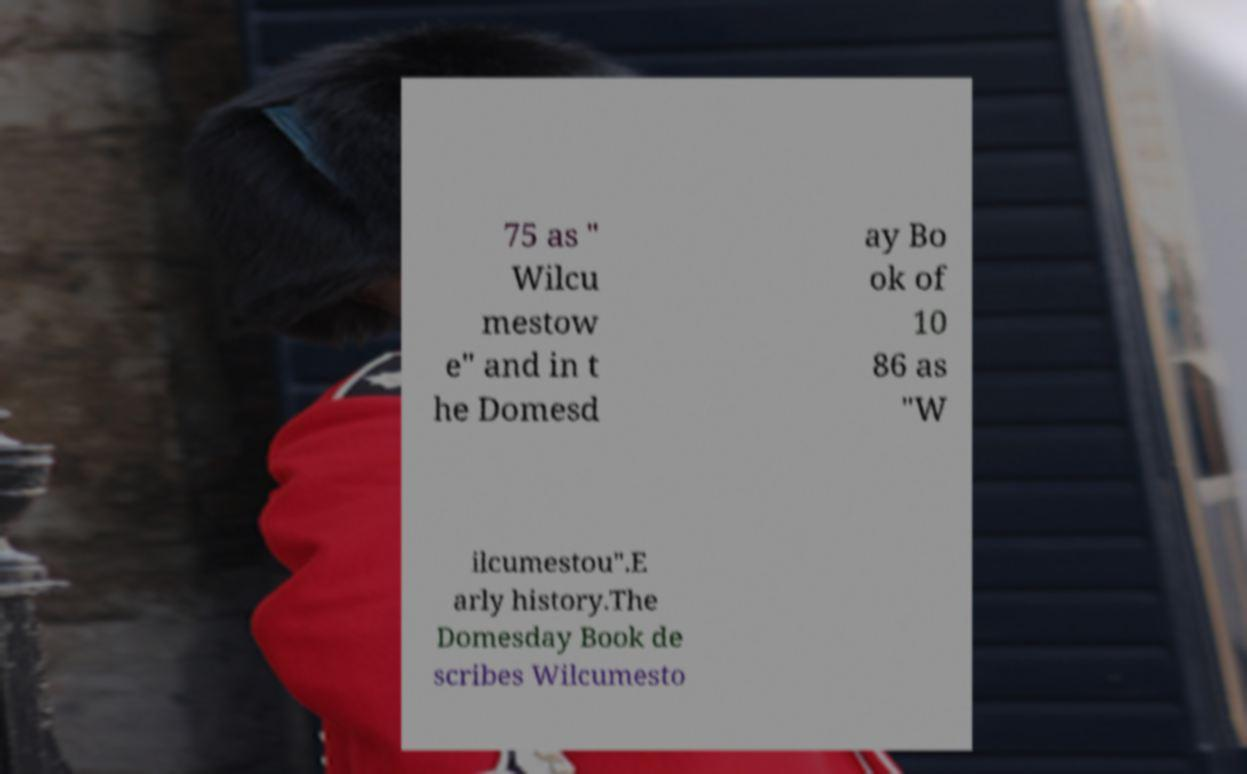Could you assist in decoding the text presented in this image and type it out clearly? 75 as " Wilcu mestow e" and in t he Domesd ay Bo ok of 10 86 as "W ilcumestou".E arly history.The Domesday Book de scribes Wilcumesto 